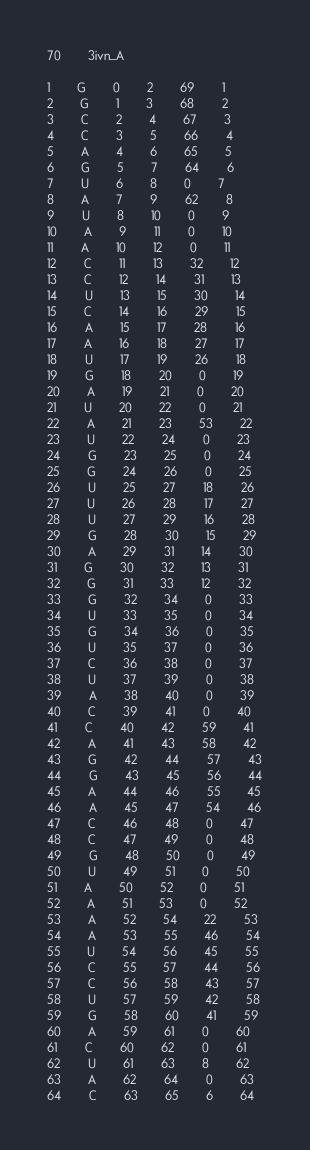Convert code to text. <code><loc_0><loc_0><loc_500><loc_500><_XML_>70		3ivn_A

1		G		0		2		69		1
2		G		1		3		68		2
3		C		2		4		67		3
4		C		3		5		66		4
5		A		4		6		65		5
6		G		5		7		64		6
7		U		6		8		0		7
8		A		7		9		62		8
9		U		8		10		0		9
10		A		9		11		0		10
11		A		10		12		0		11
12		C		11		13		32		12
13		C		12		14		31		13
14		U		13		15		30		14
15		C		14		16		29		15
16		A		15		17		28		16
17		A		16		18		27		17
18		U		17		19		26		18
19		G		18		20		0		19
20		A		19		21		0		20
21		U		20		22		0		21
22		A		21		23		53		22
23		U		22		24		0		23
24		G		23		25		0		24
25		G		24		26		0		25
26		U		25		27		18		26
27		U		26		28		17		27
28		U		27		29		16		28
29		G		28		30		15		29
30		A		29		31		14		30
31		G		30		32		13		31
32		G		31		33		12		32
33		G		32		34		0		33
34		U		33		35		0		34
35		G		34		36		0		35
36		U		35		37		0		36
37		C		36		38		0		37
38		U		37		39		0		38
39		A		38		40		0		39
40		C		39		41		0		40
41		C		40		42		59		41
42		A		41		43		58		42
43		G		42		44		57		43
44		G		43		45		56		44
45		A		44		46		55		45
46		A		45		47		54		46
47		C		46		48		0		47
48		C		47		49		0		48
49		G		48		50		0		49
50		U		49		51		0		50
51		A		50		52		0		51
52		A		51		53		0		52
53		A		52		54		22		53
54		A		53		55		46		54
55		U		54		56		45		55
56		C		55		57		44		56
57		C		56		58		43		57
58		U		57		59		42		58
59		G		58		60		41		59
60		A		59		61		0		60
61		C		60		62		0		61
62		U		61		63		8		62
63		A		62		64		0		63
64		C		63		65		6		64</code> 